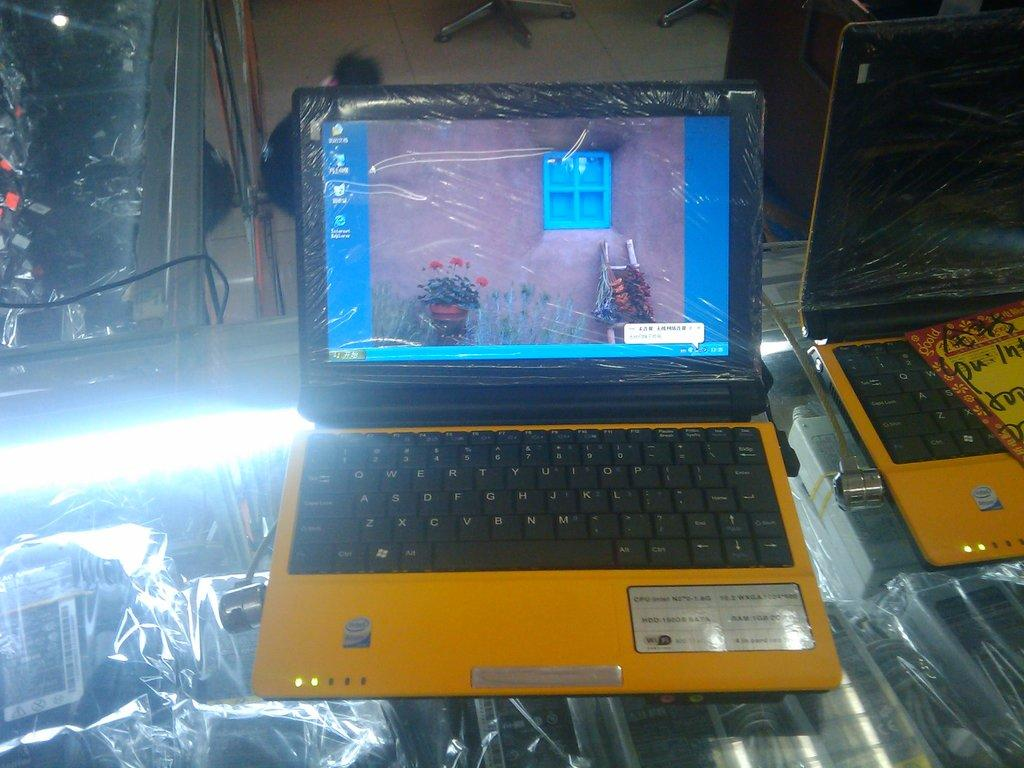<image>
Present a compact description of the photo's key features. the word intel is on a laptop that is yellow 